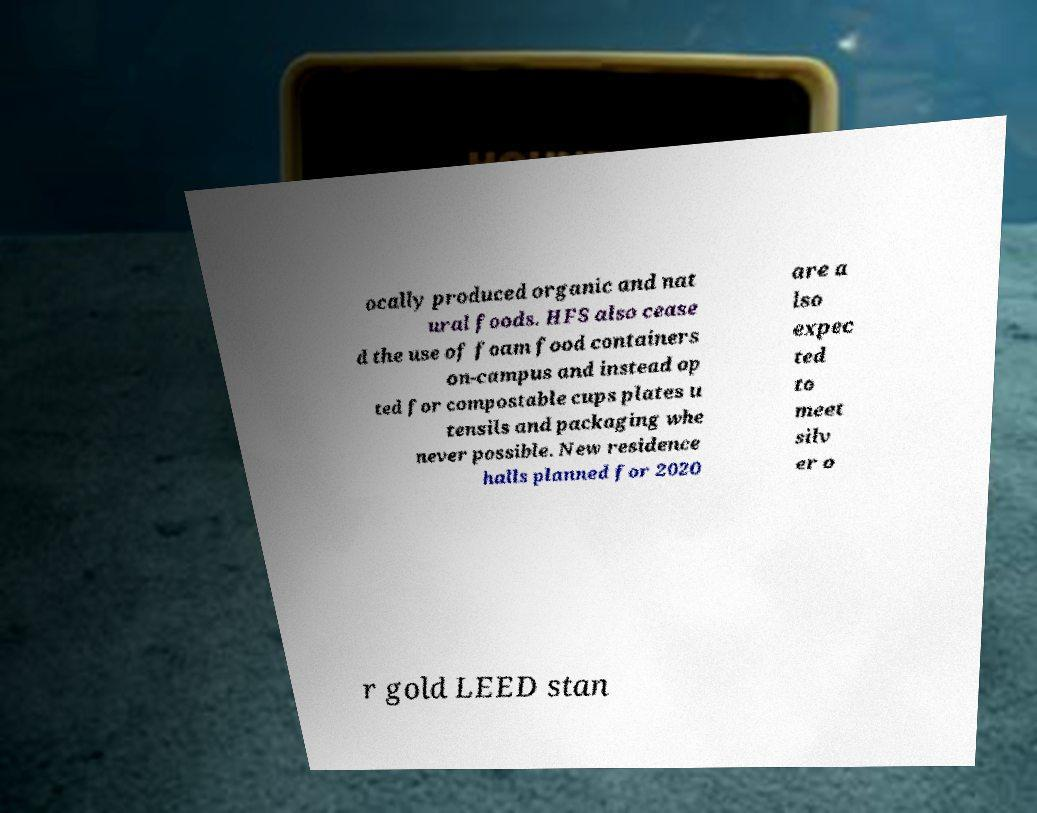I need the written content from this picture converted into text. Can you do that? ocally produced organic and nat ural foods. HFS also cease d the use of foam food containers on-campus and instead op ted for compostable cups plates u tensils and packaging whe never possible. New residence halls planned for 2020 are a lso expec ted to meet silv er o r gold LEED stan 